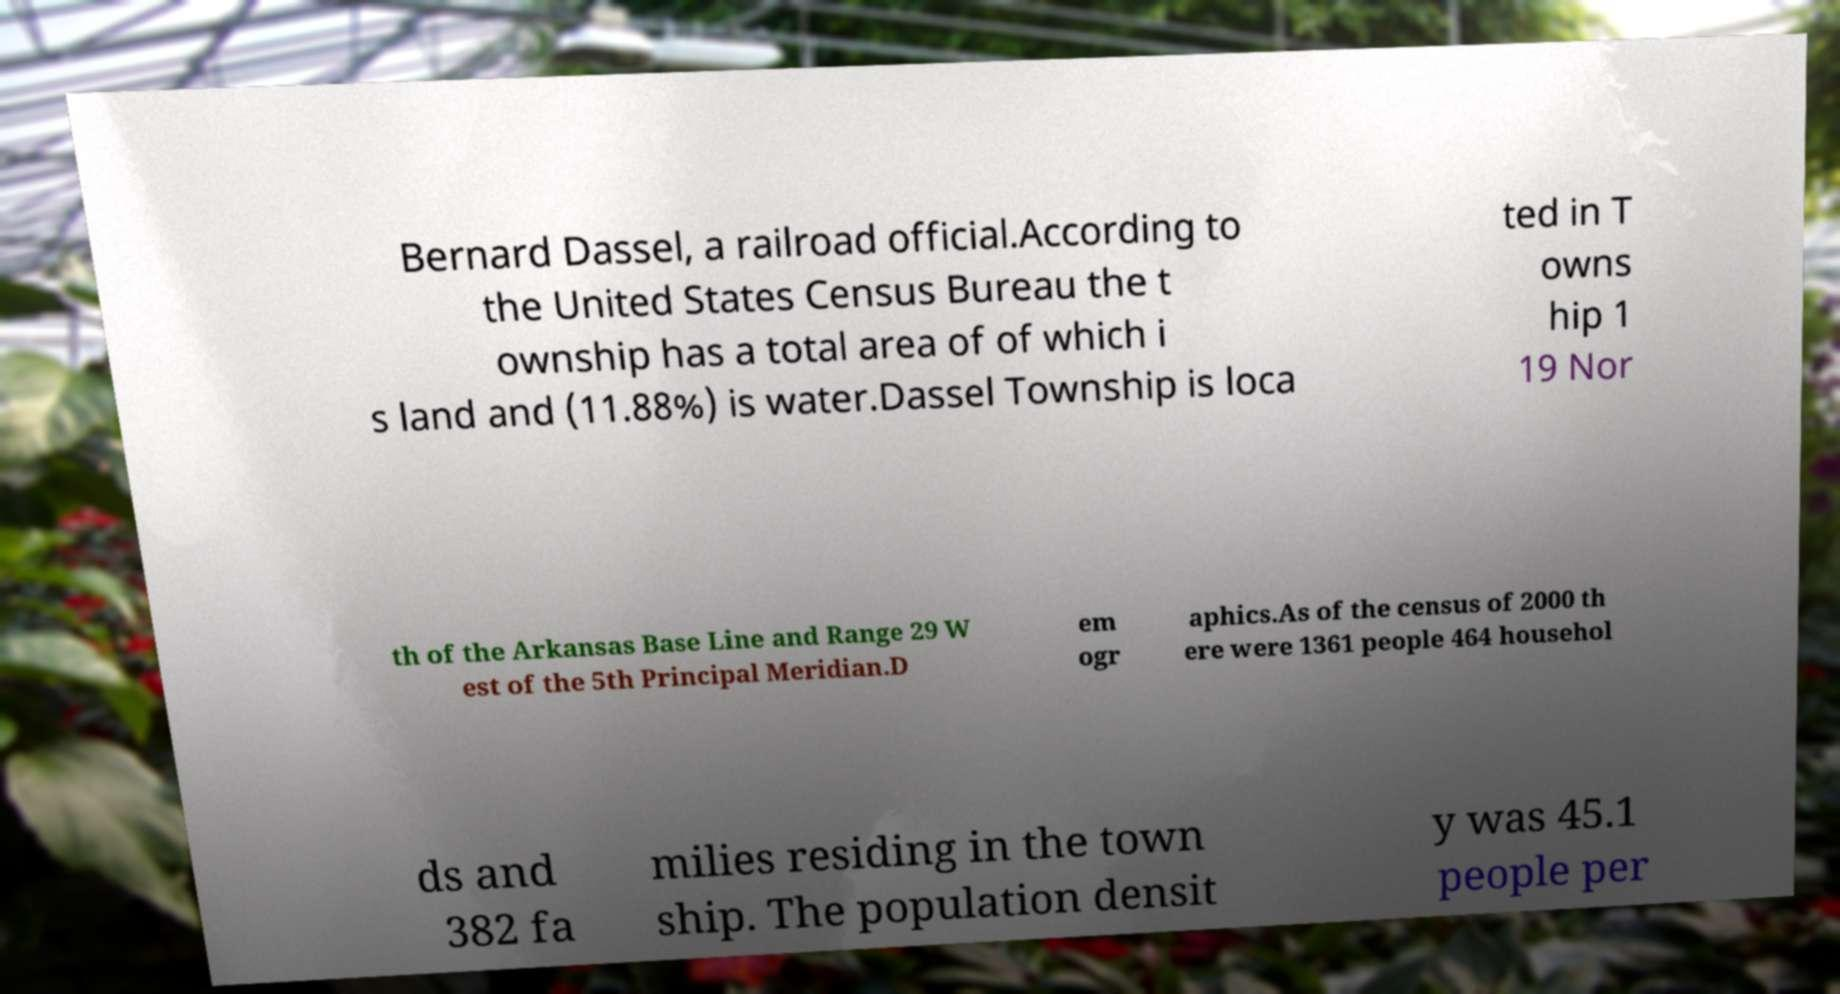Could you extract and type out the text from this image? Bernard Dassel, a railroad official.According to the United States Census Bureau the t ownship has a total area of of which i s land and (11.88%) is water.Dassel Township is loca ted in T owns hip 1 19 Nor th of the Arkansas Base Line and Range 29 W est of the 5th Principal Meridian.D em ogr aphics.As of the census of 2000 th ere were 1361 people 464 househol ds and 382 fa milies residing in the town ship. The population densit y was 45.1 people per 